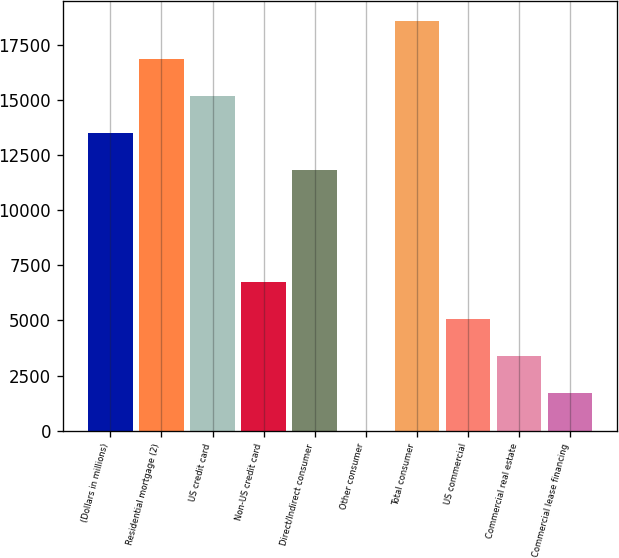<chart> <loc_0><loc_0><loc_500><loc_500><bar_chart><fcel>(Dollars in millions)<fcel>Residential mortgage (2)<fcel>US credit card<fcel>Non-US credit card<fcel>Direct/Indirect consumer<fcel>Other consumer<fcel>Total consumer<fcel>US commercial<fcel>Commercial real estate<fcel>Commercial lease financing<nl><fcel>13488.6<fcel>16860<fcel>15174.3<fcel>6745.8<fcel>11802.9<fcel>3<fcel>18545.7<fcel>5060.1<fcel>3374.4<fcel>1688.7<nl></chart> 